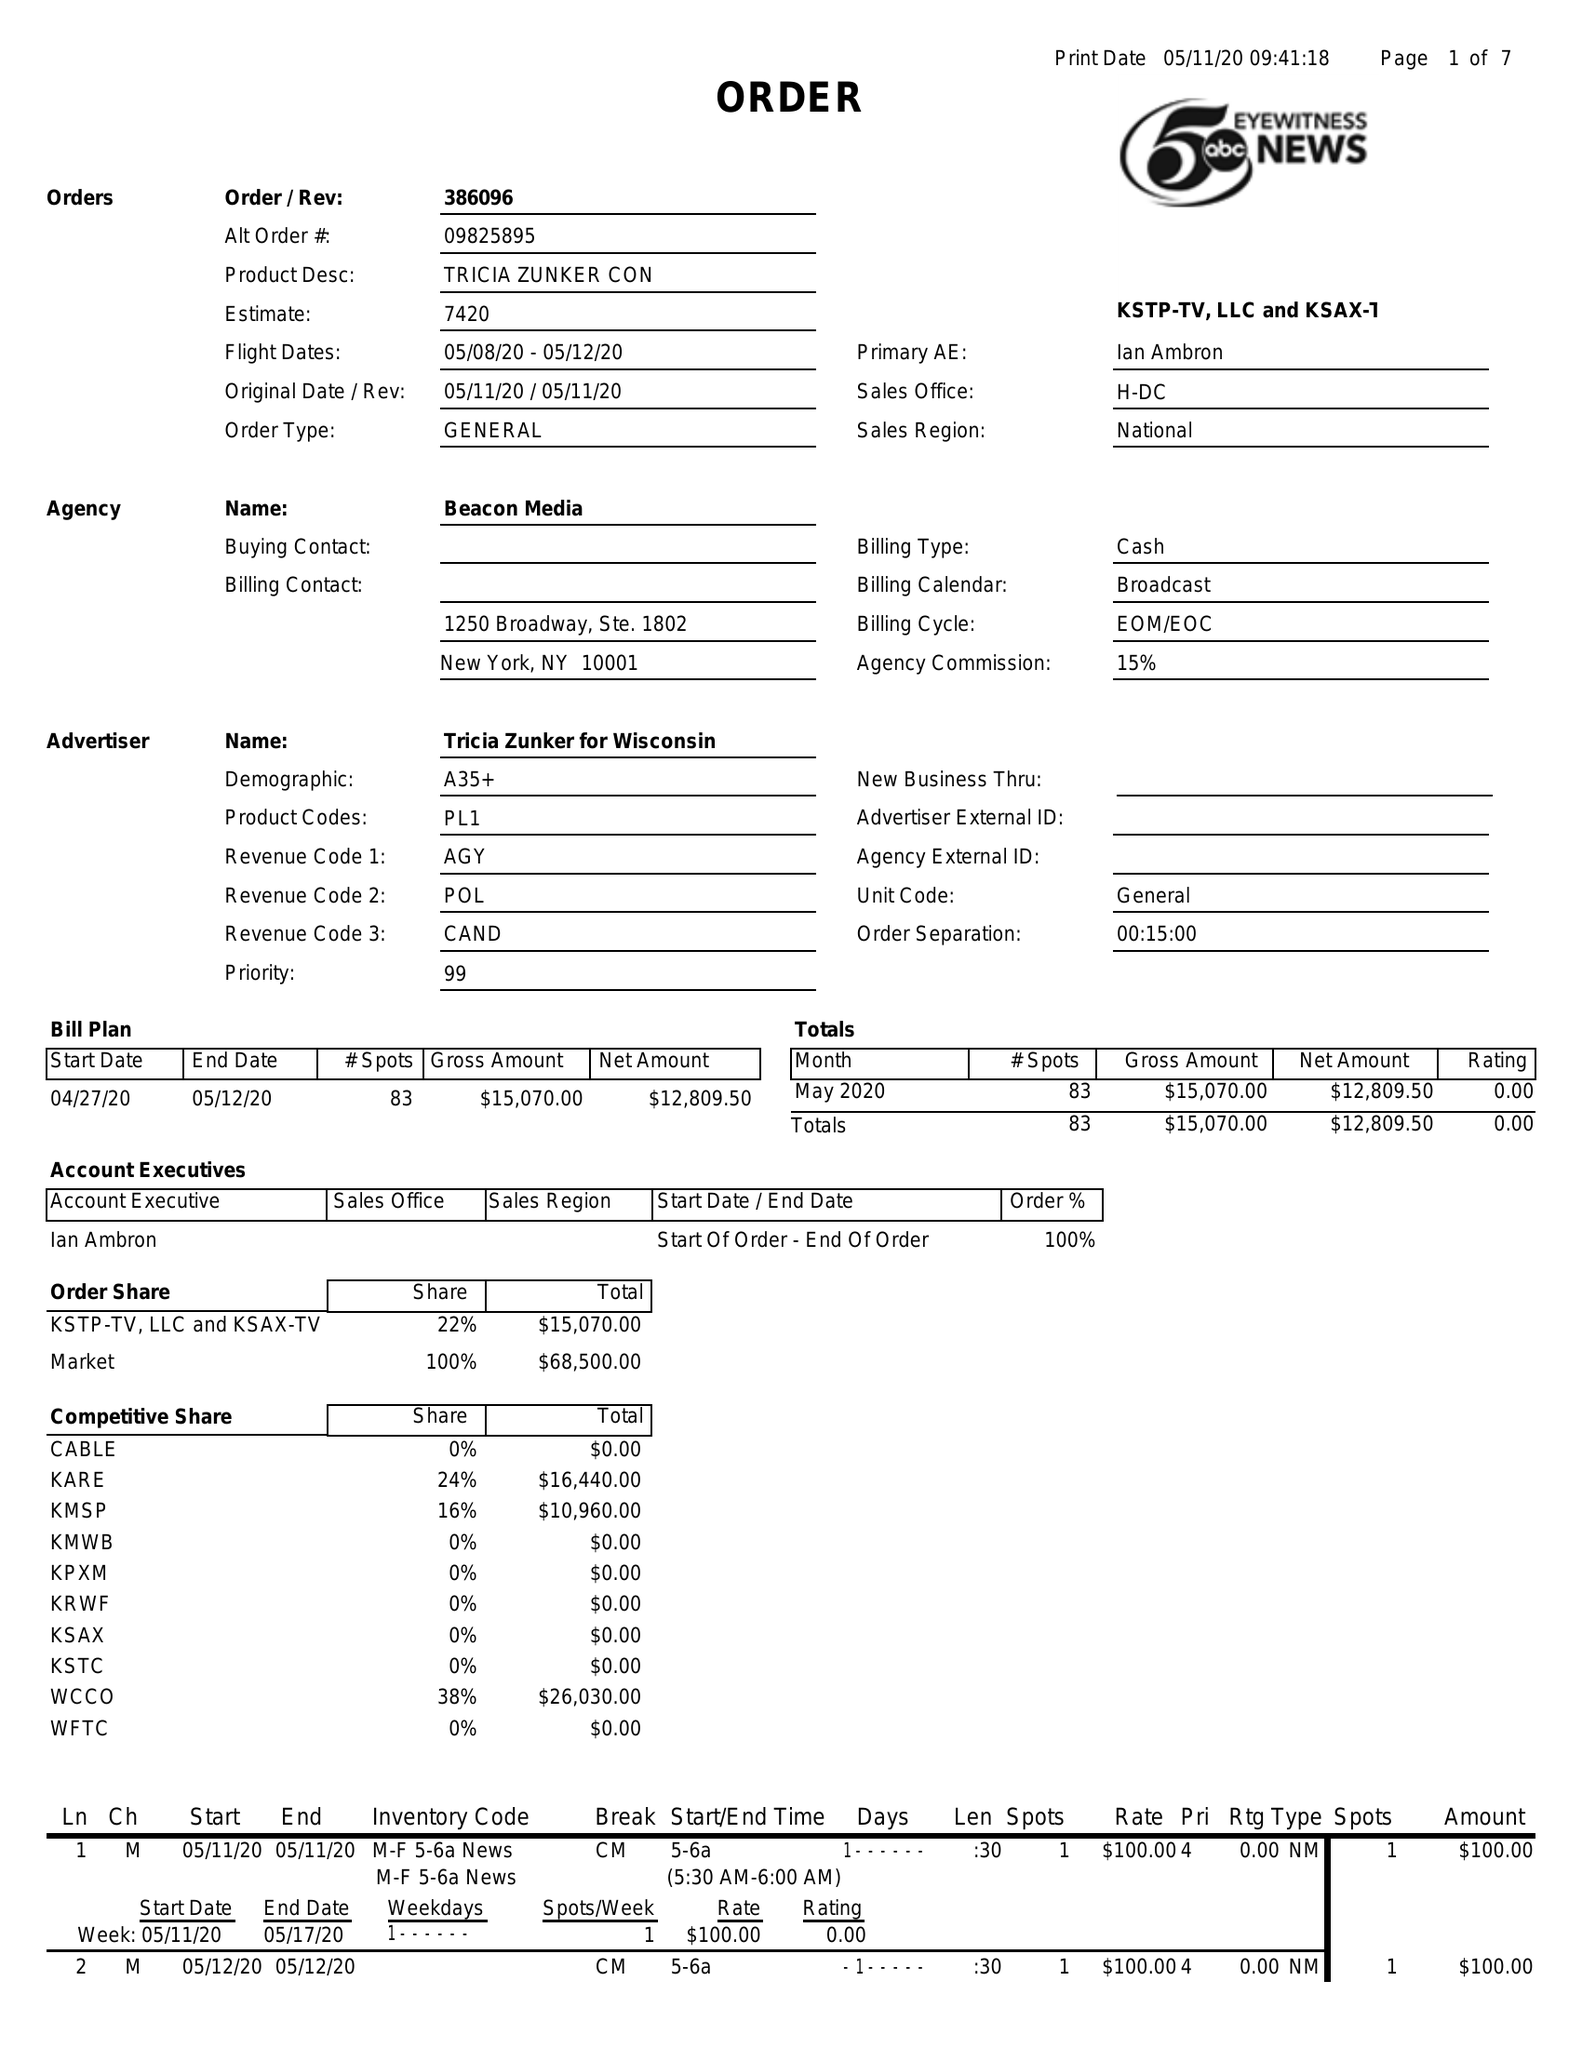What is the value for the flight_to?
Answer the question using a single word or phrase. 05/12/20 